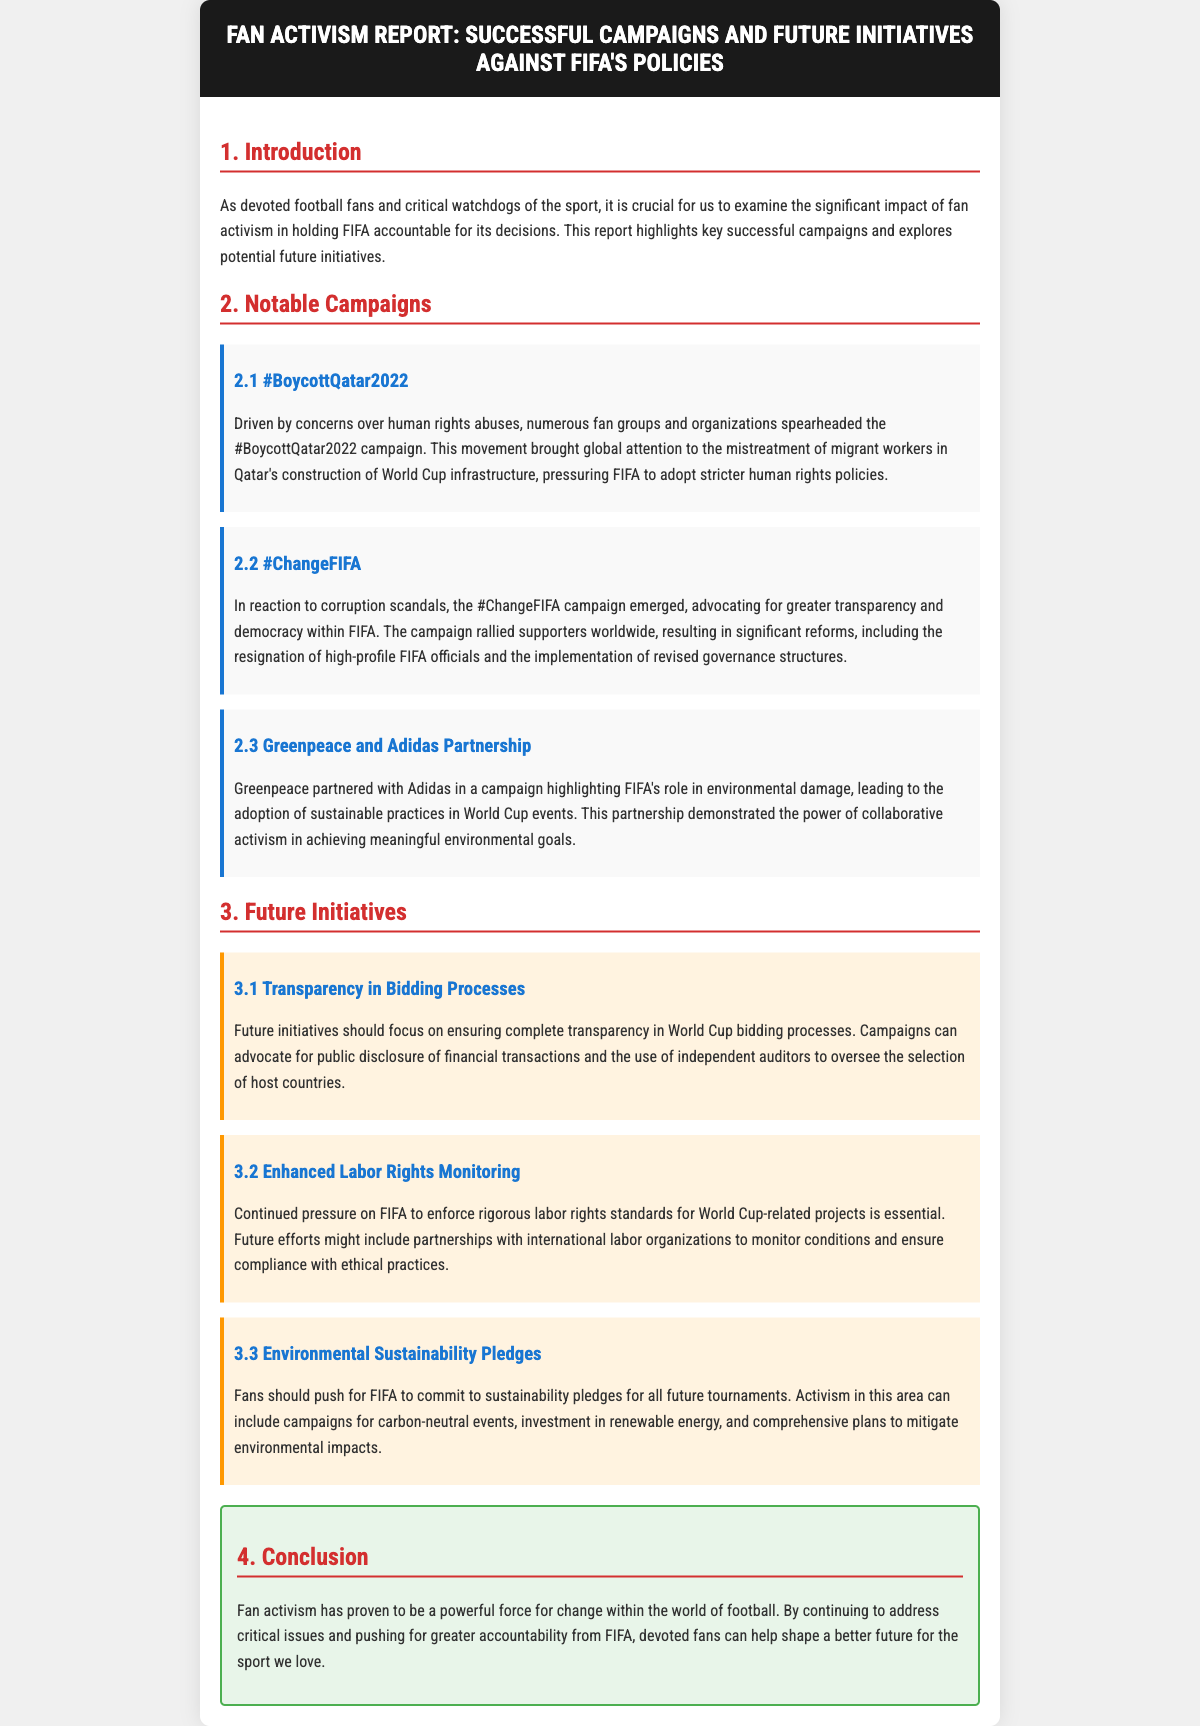What is the name of the report? The title of the report is mentioned in the header of the document.
Answer: Fan Activism Report: Successful Campaigns and Future Initiatives against FIFA's Policies What campaign highlighted human rights abuses in Qatar? The document explicitly states the campaign focused on human rights abuses related to Qatar.
Answer: #BoycottQatar2022 Which organization partnered with Adidas for environmental concerns? The document mentions a significant partnership in relation to environmental issues.
Answer: Greenpeace What initiative focuses on labor rights monitoring? The document includes specified future initiatives aimed at monitoring labor rights.
Answer: Enhanced Labor Rights Monitoring How many notable campaigns are listed in the document? The document enumerates the notable campaigns within a specific section.
Answer: Three What is one goal of future initiatives mentioned? The document outlines specific goals related to future initiatives and accountability.
Answer: Transparency in Bidding Processes What color represents successful campaigns in this report? The document uses different colors to delineate sections, including campaigns.
Answer: Blue What is emphasized as a powerful force for change? The conclusion of the document highlights a specific group driving change.
Answer: Fan activism 